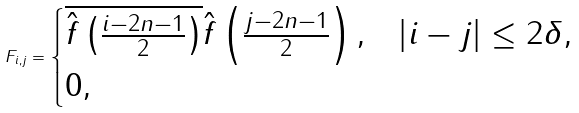Convert formula to latex. <formula><loc_0><loc_0><loc_500><loc_500>F _ { i , j } = \begin{cases} \overline { \hat { f } \left ( \frac { i - 2 n - 1 } { 2 } \right ) } \hat { f } \left ( \frac { j - 2 n - 1 } { 2 } \right ) , & \left | i - j \right | \leq 2 \delta , \\ 0 , & \end{cases}</formula> 